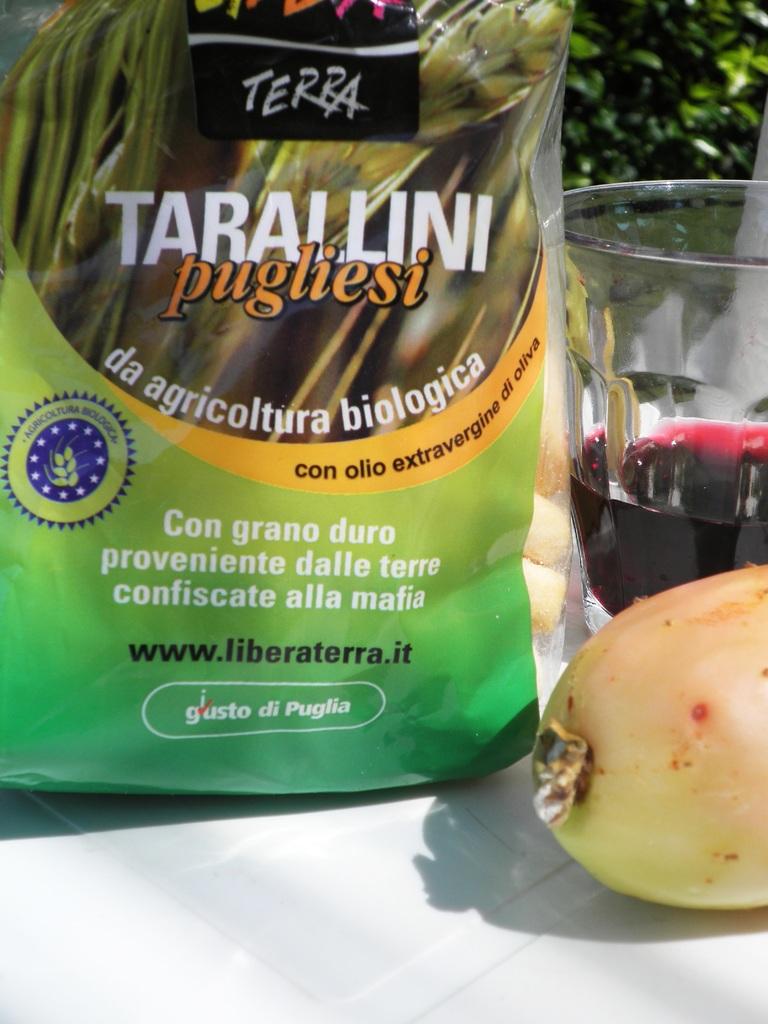What is the name of pesticide?
Offer a terse response. Tarallini. What is the website of this brand?
Provide a succinct answer. Www.liberaterra.it. 